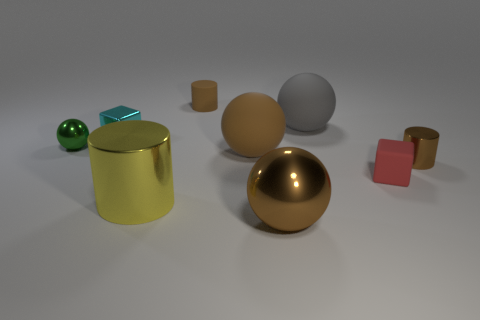There is a small matte thing that is behind the tiny metallic object behind the small green shiny ball; what is its shape?
Offer a very short reply. Cylinder. Are there fewer large shiny cylinders to the left of the red thing than small brown rubber cylinders right of the brown matte cylinder?
Keep it short and to the point. No. There is a tiny shiny thing that is the same shape as the big gray rubber object; what is its color?
Your answer should be compact. Green. What number of rubber objects are both left of the large shiny sphere and behind the cyan cube?
Your answer should be very brief. 1. Is the number of tiny brown shiny objects on the left side of the big yellow metallic cylinder greater than the number of big brown rubber spheres that are behind the tiny brown matte cylinder?
Offer a very short reply. No. What is the size of the red block?
Your answer should be very brief. Small. Is there a small green metal thing that has the same shape as the tiny cyan shiny thing?
Ensure brevity in your answer.  No. Do the small brown matte thing and the large object to the left of the tiny matte cylinder have the same shape?
Offer a very short reply. Yes. There is a object that is both behind the tiny sphere and in front of the large gray object; what is its size?
Offer a very short reply. Small. How many purple shiny spheres are there?
Keep it short and to the point. 0. 